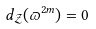<formula> <loc_0><loc_0><loc_500><loc_500>d _ { \mathcal { Z } } ( \varpi ^ { 2 m } ) = 0</formula> 